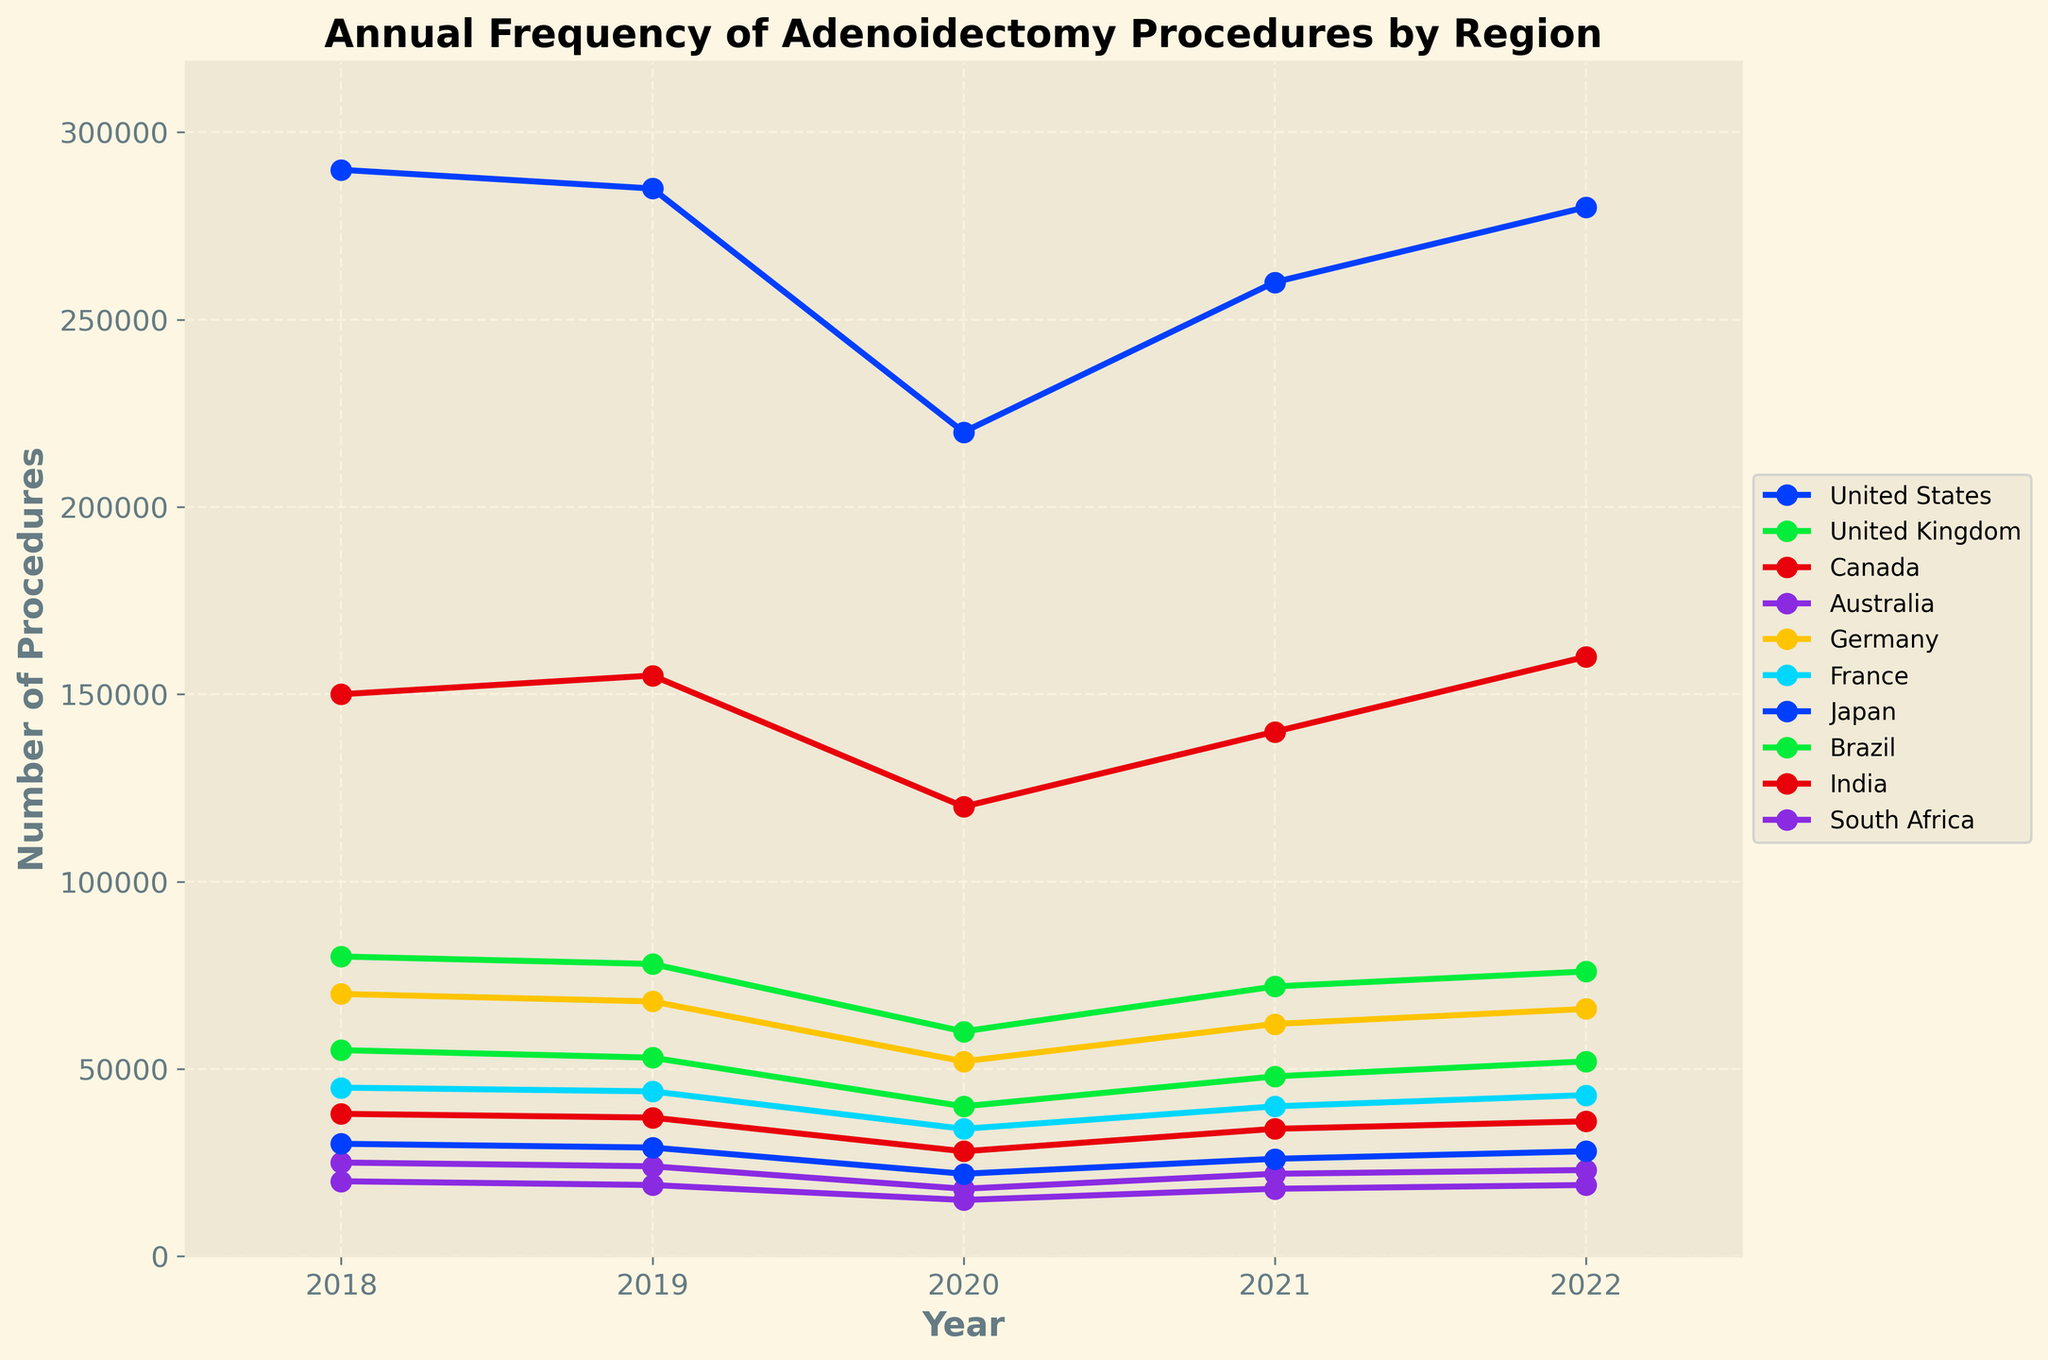What is the general trend in the number of adenoidectomy procedures in the United States from 2018 to 2022? The plot shows varying frequencies for the United States over the years. In 2018, the frequency starts at 290,000 and then decreases slightly in 2019 to 285,000. The drop continues sharply in 2020 to 220,000, then rises to 260,000 in 2021, and further increases to 280,000 in 2022. The general trend appears to be fluctuating with a significant dip in 2020 and a recovery starting in 2021.
Answer: Fluctuating with a dip in 2020 Which region had the highest number of adenoidectomy procedures in 2022? The plot indicates the number of procedures performed annually in different regions with India having the highest number in 2022, shown by the highest point on the y-axis among all regions for that year. India recorded 160,000 procedures in 2022.
Answer: India Compare the trends in adenoidectomy procedures between Canada and Australia from 2018 to 2022. Both Canada and Australia display a general trend of a decrease from 2018 to 2020, followed by a recovery starting in 2021. However, Canada's numbers are consistently higher than Australia's. Specifically, Canada's figures drop from 38,000 in 2018 to 28,000 in 2020, then increase to 36,000 by 2022. Australia's figures decrease from 25,000 in 2018 to 18,000 in 2020, and rise to 23,000 by 2022.
Answer: Both decrease till 2020, then recover; Canada always higher Summarize the change in adenoidectomy procedures in France from 2018 to 2022. In 2018, France starts with 45,000 procedures, which slightly declines to 44,000 in 2019 and drops more substantially to 34,000 in 2020. This number then rises to 40,000 in 2021 and further to 43,000 in 2022. The trend has a dip in 2020 followed by a recovery.
Answer: Dip in 2020, then recovery Which years did Germany see a rise in the number of adenoidectomy procedures, and which years saw a decline? The chart shows Germany starting at 70,000 in 2018 and declining to 68,000 in 2019 and further to 52,000 in 2020. From 2020 onwards, there's a rise to 62,000 in 2021 and to 66,000 in 2022. Hence, declines were observed in 2019 and 2020, and rises occurred in 2021 and 2022.
Answer: Decline: 2019, 2020; Rise: 2021, 2022 In 2020, which two regions had the lowest number of adenoidectomy procedures, and what were these numbers? By examining the lowest points on the graph in 2020, Australia and South Africa had the lowest numbers of adenoidectomy procedures. Australia's procedures were at 18,000 and South Africa's were at 15,000.
Answer: Australia: 18,000; South Africa: 15,000 Calculate the average number of procedures performed annually in Brazil between 2018 and 2022. Adding the figures for Brazil: 80,000 (2018) + 78,000 (2019) + 60,000 (2020) + 72,000 (2021) + 76,000 (2022) equals 366,000. The average is then 366,000 / 5 = 73,200.
Answer: 73,200 Which region experienced the most significant percentage decrease in procedures from 2019 to 2020? By calculating the percentage decrease for each region from 2019 to 2020, we find that Australia had a decrease from 24,000 to 18,000. The percentage decrease = [(24,000 - 18,000) / 24,000] * 100 = 25%. Comparing this with all other regions, Australia’s 25% is the highest percentage decrease.
Answer: Australia, 25% In which year did the United Kingdom experience the sharpest increase in the number of procedures, and what was the change? The United Kingdom's figures rise from 40,000 in 2020 to 48,000 in 2021. This increase is 8,000, which is the largest single-year increase for the U.K. during the period.
Answer: 2021; increase by 8,000 